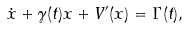<formula> <loc_0><loc_0><loc_500><loc_500>\dot { x } + \gamma ( t ) x + V ^ { \prime } ( x ) = \Gamma ( t ) ,</formula> 